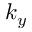Convert formula to latex. <formula><loc_0><loc_0><loc_500><loc_500>k _ { y }</formula> 